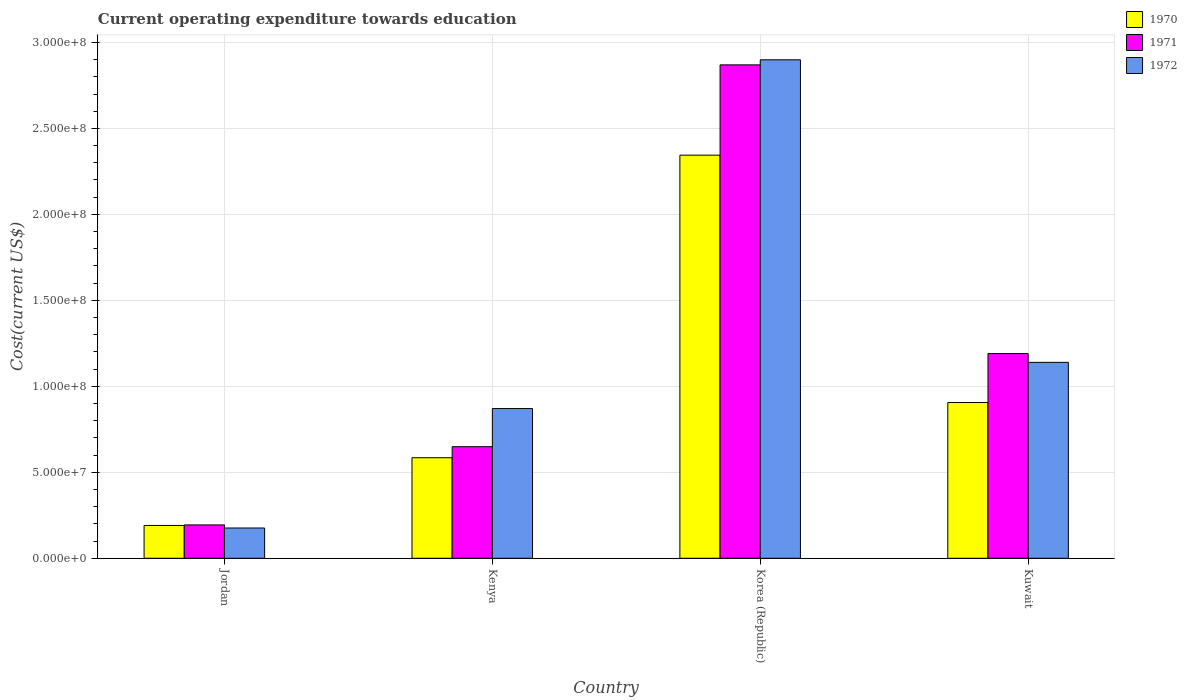How many groups of bars are there?
Your answer should be compact. 4. Are the number of bars per tick equal to the number of legend labels?
Provide a short and direct response. Yes. Are the number of bars on each tick of the X-axis equal?
Offer a very short reply. Yes. In how many cases, is the number of bars for a given country not equal to the number of legend labels?
Your answer should be very brief. 0. What is the expenditure towards education in 1970 in Kuwait?
Provide a succinct answer. 9.06e+07. Across all countries, what is the maximum expenditure towards education in 1970?
Make the answer very short. 2.34e+08. Across all countries, what is the minimum expenditure towards education in 1972?
Offer a terse response. 1.76e+07. In which country was the expenditure towards education in 1972 maximum?
Make the answer very short. Korea (Republic). In which country was the expenditure towards education in 1972 minimum?
Your response must be concise. Jordan. What is the total expenditure towards education in 1972 in the graph?
Offer a terse response. 5.09e+08. What is the difference between the expenditure towards education in 1972 in Kenya and that in Kuwait?
Make the answer very short. -2.69e+07. What is the difference between the expenditure towards education in 1971 in Kenya and the expenditure towards education in 1970 in Jordan?
Offer a very short reply. 4.58e+07. What is the average expenditure towards education in 1971 per country?
Make the answer very short. 1.23e+08. What is the difference between the expenditure towards education of/in 1972 and expenditure towards education of/in 1970 in Kuwait?
Your response must be concise. 2.34e+07. In how many countries, is the expenditure towards education in 1972 greater than 70000000 US$?
Your answer should be very brief. 3. What is the ratio of the expenditure towards education in 1971 in Jordan to that in Kuwait?
Make the answer very short. 0.16. What is the difference between the highest and the second highest expenditure towards education in 1972?
Offer a very short reply. 1.76e+08. What is the difference between the highest and the lowest expenditure towards education in 1971?
Ensure brevity in your answer.  2.68e+08. In how many countries, is the expenditure towards education in 1972 greater than the average expenditure towards education in 1972 taken over all countries?
Your answer should be very brief. 1. Is the sum of the expenditure towards education in 1970 in Kenya and Korea (Republic) greater than the maximum expenditure towards education in 1972 across all countries?
Make the answer very short. Yes. What does the 1st bar from the right in Jordan represents?
Ensure brevity in your answer.  1972. Is it the case that in every country, the sum of the expenditure towards education in 1972 and expenditure towards education in 1971 is greater than the expenditure towards education in 1970?
Your answer should be compact. Yes. How many bars are there?
Your answer should be very brief. 12. How many countries are there in the graph?
Your response must be concise. 4. What is the difference between two consecutive major ticks on the Y-axis?
Your response must be concise. 5.00e+07. Are the values on the major ticks of Y-axis written in scientific E-notation?
Offer a very short reply. Yes. Does the graph contain any zero values?
Keep it short and to the point. No. Does the graph contain grids?
Your answer should be very brief. Yes. Where does the legend appear in the graph?
Make the answer very short. Top right. How are the legend labels stacked?
Your answer should be compact. Vertical. What is the title of the graph?
Your answer should be compact. Current operating expenditure towards education. What is the label or title of the X-axis?
Provide a succinct answer. Country. What is the label or title of the Y-axis?
Offer a very short reply. Cost(current US$). What is the Cost(current US$) in 1970 in Jordan?
Make the answer very short. 1.91e+07. What is the Cost(current US$) of 1971 in Jordan?
Your answer should be very brief. 1.94e+07. What is the Cost(current US$) of 1972 in Jordan?
Keep it short and to the point. 1.76e+07. What is the Cost(current US$) of 1970 in Kenya?
Offer a terse response. 5.85e+07. What is the Cost(current US$) of 1971 in Kenya?
Provide a succinct answer. 6.49e+07. What is the Cost(current US$) of 1972 in Kenya?
Ensure brevity in your answer.  8.71e+07. What is the Cost(current US$) in 1970 in Korea (Republic)?
Provide a succinct answer. 2.34e+08. What is the Cost(current US$) in 1971 in Korea (Republic)?
Give a very brief answer. 2.87e+08. What is the Cost(current US$) of 1972 in Korea (Republic)?
Provide a succinct answer. 2.90e+08. What is the Cost(current US$) of 1970 in Kuwait?
Provide a short and direct response. 9.06e+07. What is the Cost(current US$) in 1971 in Kuwait?
Give a very brief answer. 1.19e+08. What is the Cost(current US$) of 1972 in Kuwait?
Offer a very short reply. 1.14e+08. Across all countries, what is the maximum Cost(current US$) in 1970?
Your answer should be very brief. 2.34e+08. Across all countries, what is the maximum Cost(current US$) in 1971?
Provide a succinct answer. 2.87e+08. Across all countries, what is the maximum Cost(current US$) in 1972?
Your response must be concise. 2.90e+08. Across all countries, what is the minimum Cost(current US$) of 1970?
Your answer should be very brief. 1.91e+07. Across all countries, what is the minimum Cost(current US$) of 1971?
Offer a terse response. 1.94e+07. Across all countries, what is the minimum Cost(current US$) in 1972?
Provide a succinct answer. 1.76e+07. What is the total Cost(current US$) in 1970 in the graph?
Provide a succinct answer. 4.03e+08. What is the total Cost(current US$) of 1971 in the graph?
Give a very brief answer. 4.90e+08. What is the total Cost(current US$) of 1972 in the graph?
Offer a very short reply. 5.09e+08. What is the difference between the Cost(current US$) in 1970 in Jordan and that in Kenya?
Offer a very short reply. -3.94e+07. What is the difference between the Cost(current US$) of 1971 in Jordan and that in Kenya?
Your answer should be very brief. -4.55e+07. What is the difference between the Cost(current US$) in 1972 in Jordan and that in Kenya?
Ensure brevity in your answer.  -6.95e+07. What is the difference between the Cost(current US$) of 1970 in Jordan and that in Korea (Republic)?
Your response must be concise. -2.15e+08. What is the difference between the Cost(current US$) in 1971 in Jordan and that in Korea (Republic)?
Give a very brief answer. -2.68e+08. What is the difference between the Cost(current US$) of 1972 in Jordan and that in Korea (Republic)?
Give a very brief answer. -2.72e+08. What is the difference between the Cost(current US$) in 1970 in Jordan and that in Kuwait?
Provide a short and direct response. -7.15e+07. What is the difference between the Cost(current US$) of 1971 in Jordan and that in Kuwait?
Your answer should be compact. -9.97e+07. What is the difference between the Cost(current US$) of 1972 in Jordan and that in Kuwait?
Provide a short and direct response. -9.63e+07. What is the difference between the Cost(current US$) of 1970 in Kenya and that in Korea (Republic)?
Provide a short and direct response. -1.76e+08. What is the difference between the Cost(current US$) of 1971 in Kenya and that in Korea (Republic)?
Your answer should be very brief. -2.22e+08. What is the difference between the Cost(current US$) of 1972 in Kenya and that in Korea (Republic)?
Give a very brief answer. -2.03e+08. What is the difference between the Cost(current US$) in 1970 in Kenya and that in Kuwait?
Your answer should be very brief. -3.21e+07. What is the difference between the Cost(current US$) in 1971 in Kenya and that in Kuwait?
Your answer should be compact. -5.42e+07. What is the difference between the Cost(current US$) of 1972 in Kenya and that in Kuwait?
Your answer should be compact. -2.69e+07. What is the difference between the Cost(current US$) in 1970 in Korea (Republic) and that in Kuwait?
Ensure brevity in your answer.  1.44e+08. What is the difference between the Cost(current US$) in 1971 in Korea (Republic) and that in Kuwait?
Provide a succinct answer. 1.68e+08. What is the difference between the Cost(current US$) in 1972 in Korea (Republic) and that in Kuwait?
Make the answer very short. 1.76e+08. What is the difference between the Cost(current US$) of 1970 in Jordan and the Cost(current US$) of 1971 in Kenya?
Provide a succinct answer. -4.58e+07. What is the difference between the Cost(current US$) in 1970 in Jordan and the Cost(current US$) in 1972 in Kenya?
Keep it short and to the point. -6.80e+07. What is the difference between the Cost(current US$) in 1971 in Jordan and the Cost(current US$) in 1972 in Kenya?
Offer a very short reply. -6.77e+07. What is the difference between the Cost(current US$) in 1970 in Jordan and the Cost(current US$) in 1971 in Korea (Republic)?
Keep it short and to the point. -2.68e+08. What is the difference between the Cost(current US$) in 1970 in Jordan and the Cost(current US$) in 1972 in Korea (Republic)?
Offer a very short reply. -2.71e+08. What is the difference between the Cost(current US$) in 1971 in Jordan and the Cost(current US$) in 1972 in Korea (Republic)?
Ensure brevity in your answer.  -2.71e+08. What is the difference between the Cost(current US$) of 1970 in Jordan and the Cost(current US$) of 1971 in Kuwait?
Offer a terse response. -1.00e+08. What is the difference between the Cost(current US$) in 1970 in Jordan and the Cost(current US$) in 1972 in Kuwait?
Your answer should be very brief. -9.49e+07. What is the difference between the Cost(current US$) of 1971 in Jordan and the Cost(current US$) of 1972 in Kuwait?
Your response must be concise. -9.45e+07. What is the difference between the Cost(current US$) of 1970 in Kenya and the Cost(current US$) of 1971 in Korea (Republic)?
Your answer should be compact. -2.28e+08. What is the difference between the Cost(current US$) in 1970 in Kenya and the Cost(current US$) in 1972 in Korea (Republic)?
Keep it short and to the point. -2.31e+08. What is the difference between the Cost(current US$) of 1971 in Kenya and the Cost(current US$) of 1972 in Korea (Republic)?
Your answer should be very brief. -2.25e+08. What is the difference between the Cost(current US$) in 1970 in Kenya and the Cost(current US$) in 1971 in Kuwait?
Keep it short and to the point. -6.06e+07. What is the difference between the Cost(current US$) of 1970 in Kenya and the Cost(current US$) of 1972 in Kuwait?
Provide a short and direct response. -5.55e+07. What is the difference between the Cost(current US$) in 1971 in Kenya and the Cost(current US$) in 1972 in Kuwait?
Make the answer very short. -4.91e+07. What is the difference between the Cost(current US$) in 1970 in Korea (Republic) and the Cost(current US$) in 1971 in Kuwait?
Give a very brief answer. 1.15e+08. What is the difference between the Cost(current US$) in 1970 in Korea (Republic) and the Cost(current US$) in 1972 in Kuwait?
Make the answer very short. 1.21e+08. What is the difference between the Cost(current US$) of 1971 in Korea (Republic) and the Cost(current US$) of 1972 in Kuwait?
Your answer should be compact. 1.73e+08. What is the average Cost(current US$) of 1970 per country?
Your answer should be very brief. 1.01e+08. What is the average Cost(current US$) in 1971 per country?
Your answer should be compact. 1.23e+08. What is the average Cost(current US$) of 1972 per country?
Your response must be concise. 1.27e+08. What is the difference between the Cost(current US$) of 1970 and Cost(current US$) of 1971 in Jordan?
Offer a very short reply. -3.14e+05. What is the difference between the Cost(current US$) in 1970 and Cost(current US$) in 1972 in Jordan?
Make the answer very short. 1.49e+06. What is the difference between the Cost(current US$) in 1971 and Cost(current US$) in 1972 in Jordan?
Provide a succinct answer. 1.80e+06. What is the difference between the Cost(current US$) in 1970 and Cost(current US$) in 1971 in Kenya?
Your response must be concise. -6.41e+06. What is the difference between the Cost(current US$) of 1970 and Cost(current US$) of 1972 in Kenya?
Provide a short and direct response. -2.86e+07. What is the difference between the Cost(current US$) in 1971 and Cost(current US$) in 1972 in Kenya?
Keep it short and to the point. -2.22e+07. What is the difference between the Cost(current US$) in 1970 and Cost(current US$) in 1971 in Korea (Republic)?
Keep it short and to the point. -5.25e+07. What is the difference between the Cost(current US$) in 1970 and Cost(current US$) in 1972 in Korea (Republic)?
Provide a short and direct response. -5.55e+07. What is the difference between the Cost(current US$) of 1971 and Cost(current US$) of 1972 in Korea (Republic)?
Offer a terse response. -2.95e+06. What is the difference between the Cost(current US$) of 1970 and Cost(current US$) of 1971 in Kuwait?
Ensure brevity in your answer.  -2.85e+07. What is the difference between the Cost(current US$) in 1970 and Cost(current US$) in 1972 in Kuwait?
Ensure brevity in your answer.  -2.34e+07. What is the difference between the Cost(current US$) in 1971 and Cost(current US$) in 1972 in Kuwait?
Offer a terse response. 5.13e+06. What is the ratio of the Cost(current US$) in 1970 in Jordan to that in Kenya?
Give a very brief answer. 0.33. What is the ratio of the Cost(current US$) in 1971 in Jordan to that in Kenya?
Offer a very short reply. 0.3. What is the ratio of the Cost(current US$) of 1972 in Jordan to that in Kenya?
Keep it short and to the point. 0.2. What is the ratio of the Cost(current US$) of 1970 in Jordan to that in Korea (Republic)?
Provide a succinct answer. 0.08. What is the ratio of the Cost(current US$) of 1971 in Jordan to that in Korea (Republic)?
Offer a terse response. 0.07. What is the ratio of the Cost(current US$) in 1972 in Jordan to that in Korea (Republic)?
Your answer should be very brief. 0.06. What is the ratio of the Cost(current US$) of 1970 in Jordan to that in Kuwait?
Offer a very short reply. 0.21. What is the ratio of the Cost(current US$) of 1971 in Jordan to that in Kuwait?
Your answer should be compact. 0.16. What is the ratio of the Cost(current US$) of 1972 in Jordan to that in Kuwait?
Your answer should be very brief. 0.15. What is the ratio of the Cost(current US$) of 1970 in Kenya to that in Korea (Republic)?
Your answer should be very brief. 0.25. What is the ratio of the Cost(current US$) in 1971 in Kenya to that in Korea (Republic)?
Your response must be concise. 0.23. What is the ratio of the Cost(current US$) of 1972 in Kenya to that in Korea (Republic)?
Provide a short and direct response. 0.3. What is the ratio of the Cost(current US$) of 1970 in Kenya to that in Kuwait?
Give a very brief answer. 0.65. What is the ratio of the Cost(current US$) of 1971 in Kenya to that in Kuwait?
Offer a very short reply. 0.55. What is the ratio of the Cost(current US$) in 1972 in Kenya to that in Kuwait?
Offer a terse response. 0.76. What is the ratio of the Cost(current US$) of 1970 in Korea (Republic) to that in Kuwait?
Your response must be concise. 2.59. What is the ratio of the Cost(current US$) in 1971 in Korea (Republic) to that in Kuwait?
Provide a short and direct response. 2.41. What is the ratio of the Cost(current US$) of 1972 in Korea (Republic) to that in Kuwait?
Offer a very short reply. 2.54. What is the difference between the highest and the second highest Cost(current US$) of 1970?
Give a very brief answer. 1.44e+08. What is the difference between the highest and the second highest Cost(current US$) of 1971?
Your answer should be very brief. 1.68e+08. What is the difference between the highest and the second highest Cost(current US$) in 1972?
Ensure brevity in your answer.  1.76e+08. What is the difference between the highest and the lowest Cost(current US$) of 1970?
Provide a succinct answer. 2.15e+08. What is the difference between the highest and the lowest Cost(current US$) in 1971?
Offer a very short reply. 2.68e+08. What is the difference between the highest and the lowest Cost(current US$) of 1972?
Your answer should be compact. 2.72e+08. 